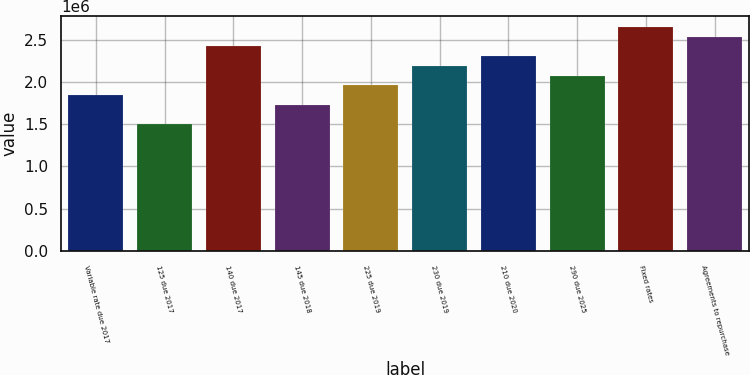Convert chart to OTSL. <chart><loc_0><loc_0><loc_500><loc_500><bar_chart><fcel>Variable rate due 2017<fcel>125 due 2017<fcel>140 due 2017<fcel>145 due 2018<fcel>225 due 2019<fcel>230 due 2019<fcel>210 due 2020<fcel>290 due 2025<fcel>Fixed rates<fcel>Agreements to repurchase<nl><fcel>1.84361e+06<fcel>1.49917e+06<fcel>2.41767e+06<fcel>1.7288e+06<fcel>1.95842e+06<fcel>2.18804e+06<fcel>2.30285e+06<fcel>2.07323e+06<fcel>2.64729e+06<fcel>2.53248e+06<nl></chart> 